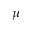<formula> <loc_0><loc_0><loc_500><loc_500>\mu</formula> 